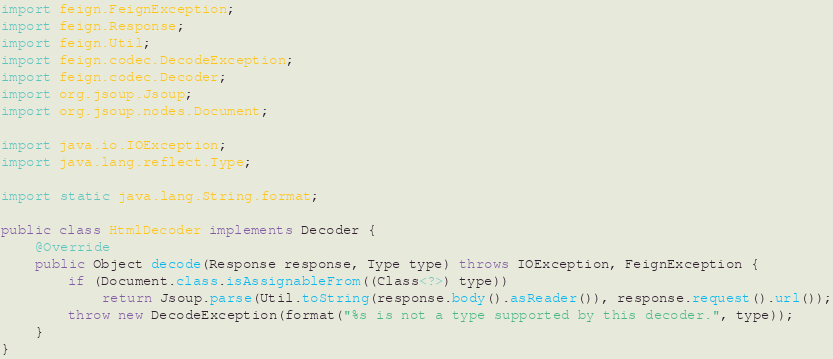Convert code to text. <code><loc_0><loc_0><loc_500><loc_500><_Java_>import feign.FeignException;
import feign.Response;
import feign.Util;
import feign.codec.DecodeException;
import feign.codec.Decoder;
import org.jsoup.Jsoup;
import org.jsoup.nodes.Document;

import java.io.IOException;
import java.lang.reflect.Type;

import static java.lang.String.format;

public class HtmlDecoder implements Decoder {
    @Override
    public Object decode(Response response, Type type) throws IOException, FeignException {
        if (Document.class.isAssignableFrom((Class<?>) type))
            return Jsoup.parse(Util.toString(response.body().asReader()), response.request().url());
        throw new DecodeException(format("%s is not a type supported by this decoder.", type));
    }
}
</code> 